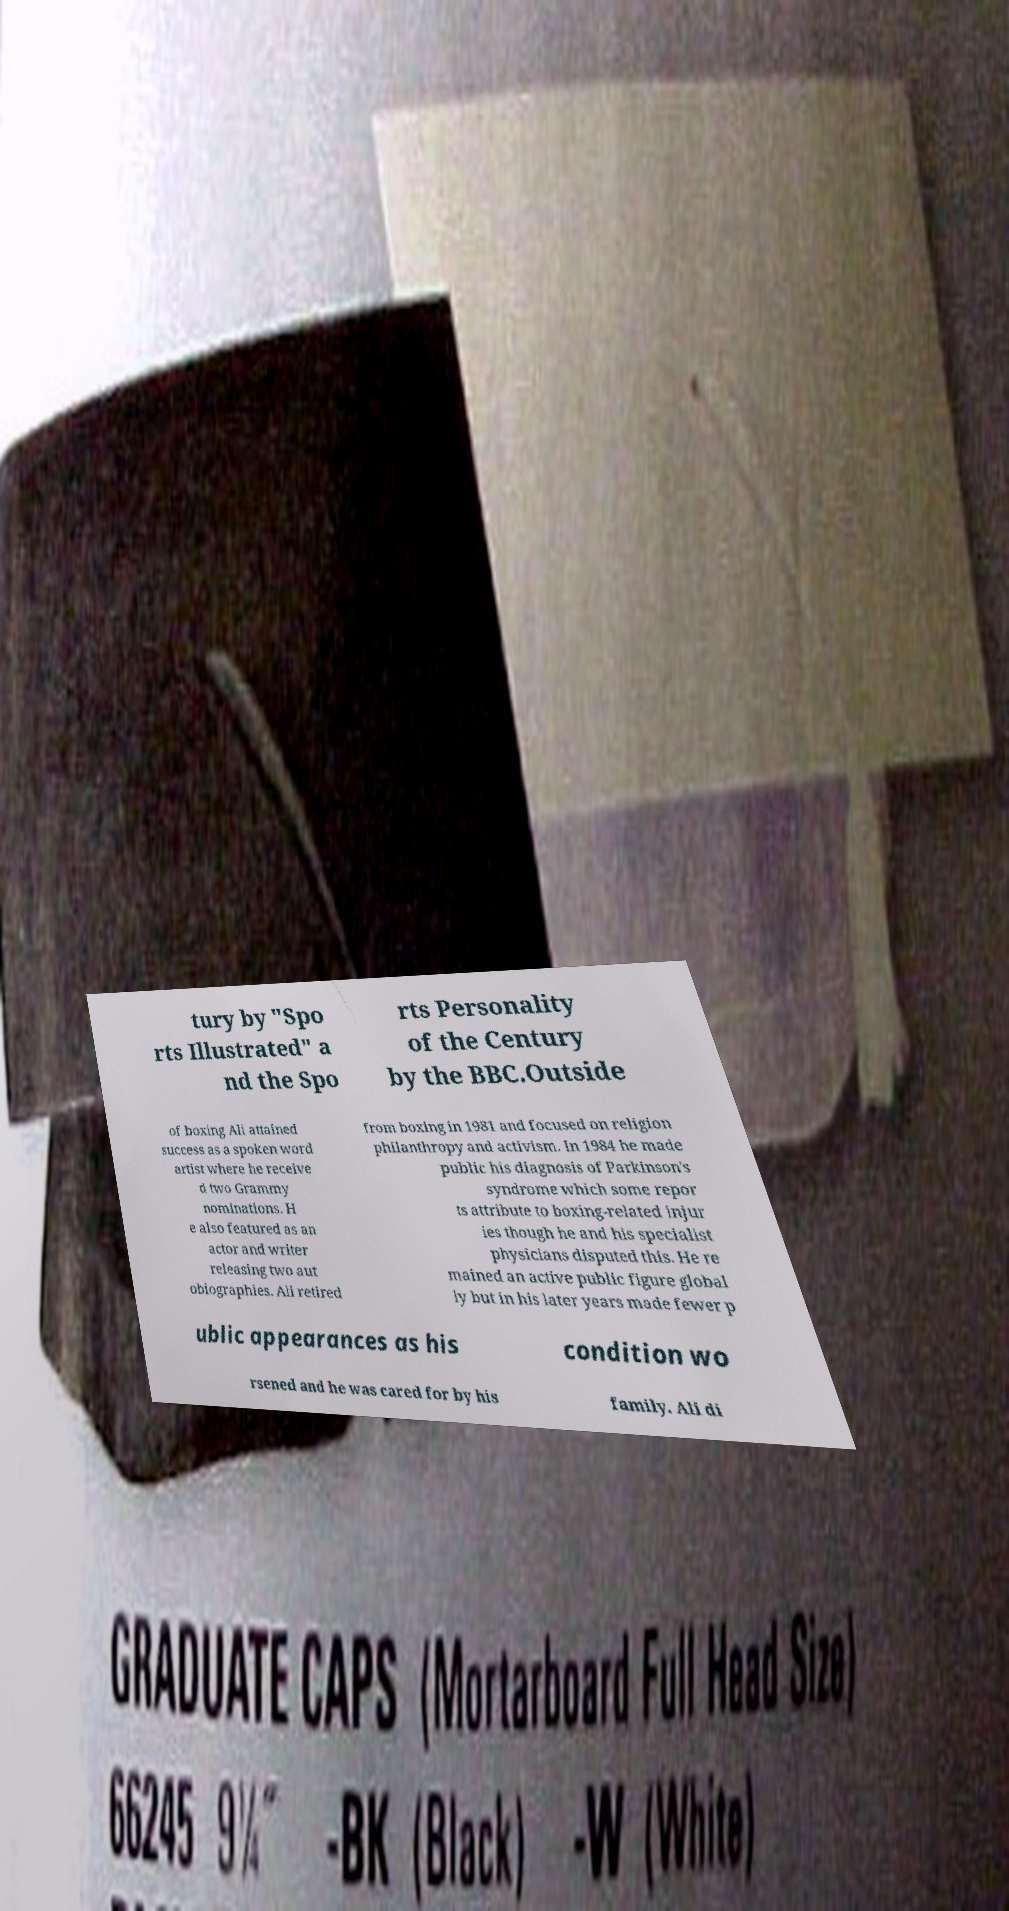There's text embedded in this image that I need extracted. Can you transcribe it verbatim? tury by "Spo rts Illustrated" a nd the Spo rts Personality of the Century by the BBC.Outside of boxing Ali attained success as a spoken word artist where he receive d two Grammy nominations. H e also featured as an actor and writer releasing two aut obiographies. Ali retired from boxing in 1981 and focused on religion philanthropy and activism. In 1984 he made public his diagnosis of Parkinson's syndrome which some repor ts attribute to boxing-related injur ies though he and his specialist physicians disputed this. He re mained an active public figure global ly but in his later years made fewer p ublic appearances as his condition wo rsened and he was cared for by his family. Ali di 